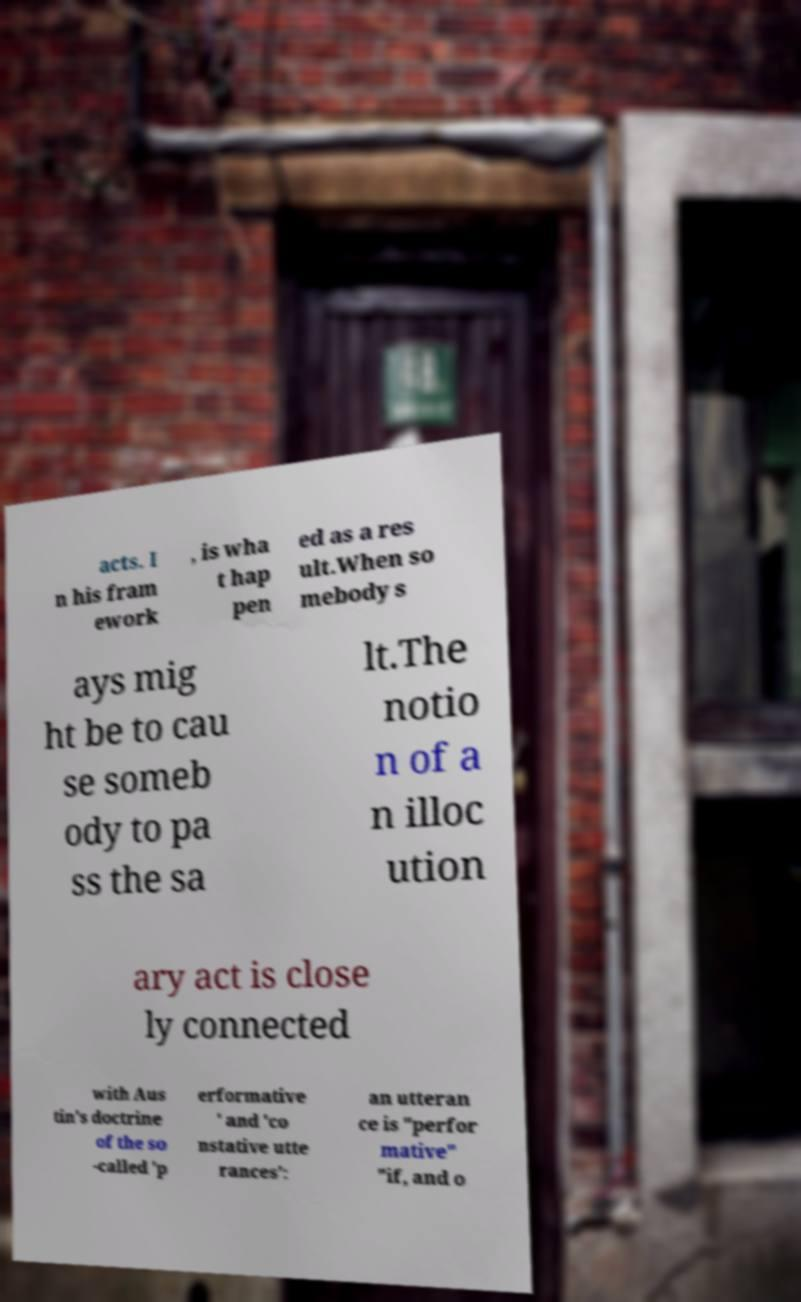Could you assist in decoding the text presented in this image and type it out clearly? acts. I n his fram ework , is wha t hap pen ed as a res ult.When so mebody s ays mig ht be to cau se someb ody to pa ss the sa lt.The notio n of a n illoc ution ary act is close ly connected with Aus tin's doctrine of the so -called 'p erformative ' and 'co nstative utte rances': an utteran ce is "perfor mative" "if, and o 